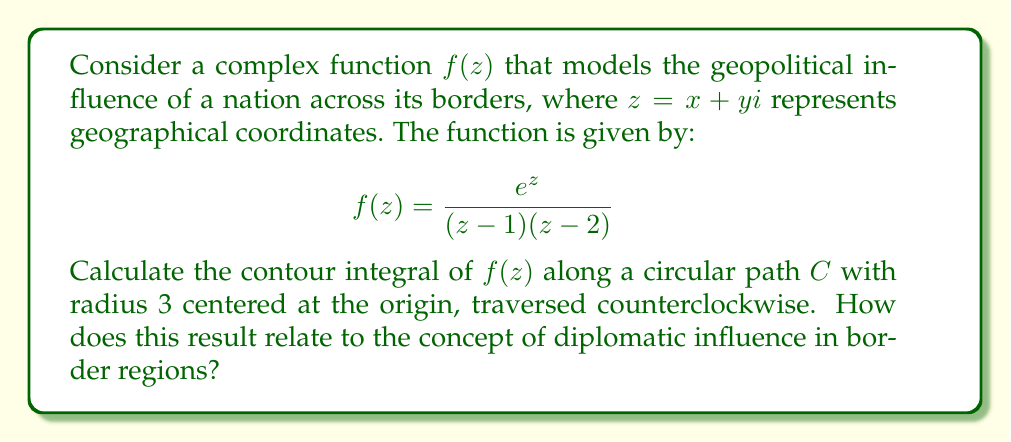Help me with this question. To solve this problem, we'll use the Residue Theorem from complex analysis, which states that for a closed contour $C$:

$$\oint_C f(z) dz = 2\pi i \sum_{k=1}^n \text{Res}(f, a_k)$$

where $a_k$ are the poles of $f(z)$ inside $C$.

1) First, identify the poles of $f(z)$:
   The poles are at $z=1$ and $z=2$, both of which lie inside our contour.

2) Calculate the residues:
   At $z=1$: $\text{Res}(f,1) = \lim_{z\to 1} (z-1)f(z) = \lim_{z\to 1} \frac{e^z}{z-2} = -e$
   At $z=2$: $\text{Res}(f,2) = \lim_{z\to 2} (z-2)f(z) = \lim_{z\to 2} \frac{e^z}{z-1} = e^2$

3) Apply the Residue Theorem:
   $$\oint_C f(z) dz = 2\pi i (\text{Res}(f,1) + \text{Res}(f,2))$$
   $$= 2\pi i (-e + e^2)$$
   $$= 2\pi i e(e-1)$$

4) Relating to diplomatic influence:
   The result represents the net influence across all border regions. The positive value indicates a net outward flow of influence. The exponential terms in the answer reflect the exponential nature of diplomatic relationships and influence propagation.
Answer: $$2\pi i e(e-1)$$
This complex value represents the net geopolitical influence across borders, with the magnitude indicating strength and the argument indicating the overall direction of influence flow. 